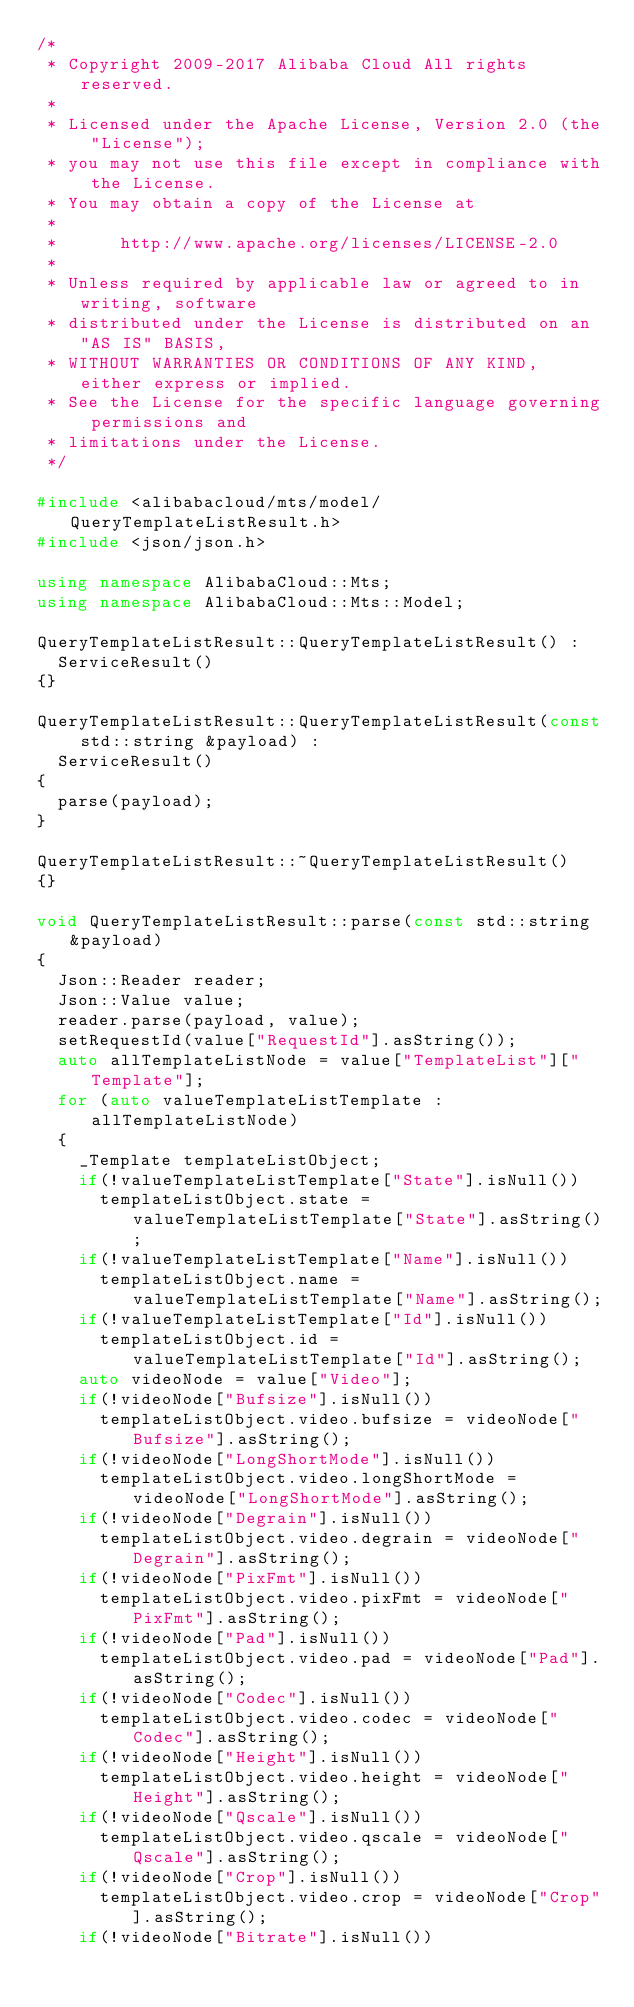Convert code to text. <code><loc_0><loc_0><loc_500><loc_500><_C++_>/*
 * Copyright 2009-2017 Alibaba Cloud All rights reserved.
 * 
 * Licensed under the Apache License, Version 2.0 (the "License");
 * you may not use this file except in compliance with the License.
 * You may obtain a copy of the License at
 * 
 *      http://www.apache.org/licenses/LICENSE-2.0
 * 
 * Unless required by applicable law or agreed to in writing, software
 * distributed under the License is distributed on an "AS IS" BASIS,
 * WITHOUT WARRANTIES OR CONDITIONS OF ANY KIND, either express or implied.
 * See the License for the specific language governing permissions and
 * limitations under the License.
 */

#include <alibabacloud/mts/model/QueryTemplateListResult.h>
#include <json/json.h>

using namespace AlibabaCloud::Mts;
using namespace AlibabaCloud::Mts::Model;

QueryTemplateListResult::QueryTemplateListResult() :
	ServiceResult()
{}

QueryTemplateListResult::QueryTemplateListResult(const std::string &payload) :
	ServiceResult()
{
	parse(payload);
}

QueryTemplateListResult::~QueryTemplateListResult()
{}

void QueryTemplateListResult::parse(const std::string &payload)
{
	Json::Reader reader;
	Json::Value value;
	reader.parse(payload, value);
	setRequestId(value["RequestId"].asString());
	auto allTemplateListNode = value["TemplateList"]["Template"];
	for (auto valueTemplateListTemplate : allTemplateListNode)
	{
		_Template templateListObject;
		if(!valueTemplateListTemplate["State"].isNull())
			templateListObject.state = valueTemplateListTemplate["State"].asString();
		if(!valueTemplateListTemplate["Name"].isNull())
			templateListObject.name = valueTemplateListTemplate["Name"].asString();
		if(!valueTemplateListTemplate["Id"].isNull())
			templateListObject.id = valueTemplateListTemplate["Id"].asString();
		auto videoNode = value["Video"];
		if(!videoNode["Bufsize"].isNull())
			templateListObject.video.bufsize = videoNode["Bufsize"].asString();
		if(!videoNode["LongShortMode"].isNull())
			templateListObject.video.longShortMode = videoNode["LongShortMode"].asString();
		if(!videoNode["Degrain"].isNull())
			templateListObject.video.degrain = videoNode["Degrain"].asString();
		if(!videoNode["PixFmt"].isNull())
			templateListObject.video.pixFmt = videoNode["PixFmt"].asString();
		if(!videoNode["Pad"].isNull())
			templateListObject.video.pad = videoNode["Pad"].asString();
		if(!videoNode["Codec"].isNull())
			templateListObject.video.codec = videoNode["Codec"].asString();
		if(!videoNode["Height"].isNull())
			templateListObject.video.height = videoNode["Height"].asString();
		if(!videoNode["Qscale"].isNull())
			templateListObject.video.qscale = videoNode["Qscale"].asString();
		if(!videoNode["Crop"].isNull())
			templateListObject.video.crop = videoNode["Crop"].asString();
		if(!videoNode["Bitrate"].isNull())</code> 